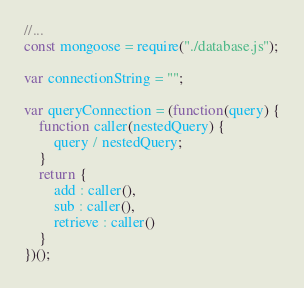Convert code to text. <code><loc_0><loc_0><loc_500><loc_500><_JavaScript_>//...
const mongoose = require("./database.js");

var connectionString = "";

var queryConnection = (function(query) {
    function caller(nestedQuery) {
        query / nestedQuery;
    }
    return {
        add : caller(),
        sub : caller(),
        retrieve : caller()
    }
})();</code> 